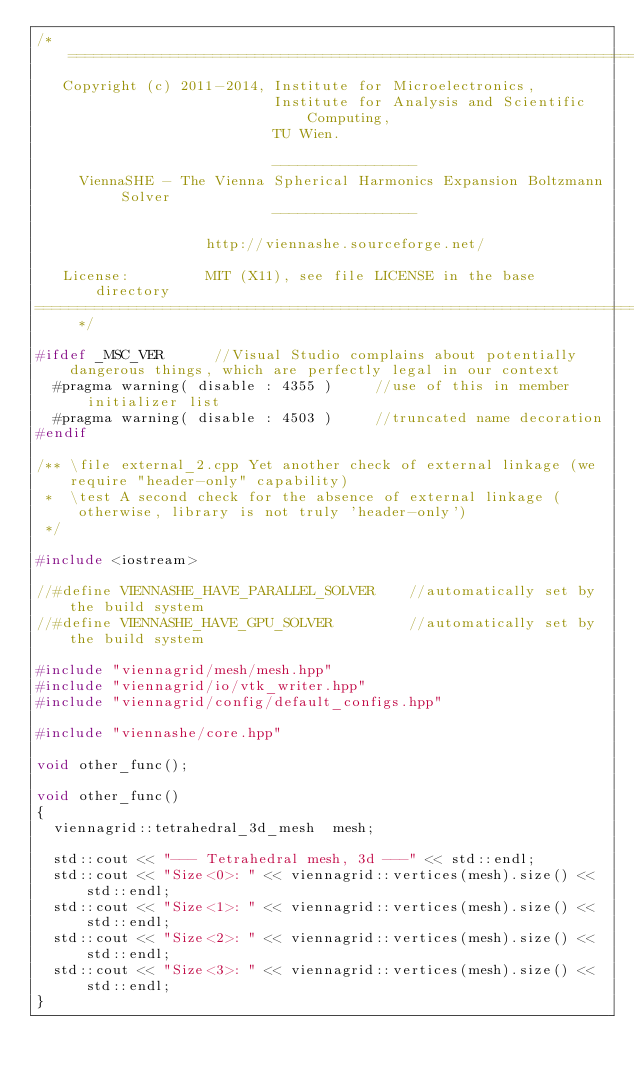Convert code to text. <code><loc_0><loc_0><loc_500><loc_500><_C++_>/* ============================================================================
   Copyright (c) 2011-2014, Institute for Microelectronics,
                            Institute for Analysis and Scientific Computing,
                            TU Wien.

                            -----------------
     ViennaSHE - The Vienna Spherical Harmonics Expansion Boltzmann Solver
                            -----------------

                    http://viennashe.sourceforge.net/

   License:         MIT (X11), see file LICENSE in the base directory
=============================================================================== */

#ifdef _MSC_VER      //Visual Studio complains about potentially dangerous things, which are perfectly legal in our context
  #pragma warning( disable : 4355 )     //use of this in member initializer list
  #pragma warning( disable : 4503 )     //truncated name decoration
#endif

/** \file external_2.cpp Yet another check of external linkage (we require "header-only" capability)
 *  \test A second check for the absence of external linkage (otherwise, library is not truly 'header-only')
 */

#include <iostream>

//#define VIENNASHE_HAVE_PARALLEL_SOLVER    //automatically set by the build system
//#define VIENNASHE_HAVE_GPU_SOLVER         //automatically set by the build system

#include "viennagrid/mesh/mesh.hpp"
#include "viennagrid/io/vtk_writer.hpp"
#include "viennagrid/config/default_configs.hpp"

#include "viennashe/core.hpp"

void other_func();

void other_func()
{
  viennagrid::tetrahedral_3d_mesh  mesh;

  std::cout << "--- Tetrahedral mesh, 3d ---" << std::endl;
  std::cout << "Size<0>: " << viennagrid::vertices(mesh).size() << std::endl;
  std::cout << "Size<1>: " << viennagrid::vertices(mesh).size() << std::endl;
  std::cout << "Size<2>: " << viennagrid::vertices(mesh).size() << std::endl;
  std::cout << "Size<3>: " << viennagrid::vertices(mesh).size() << std::endl;
}
</code> 